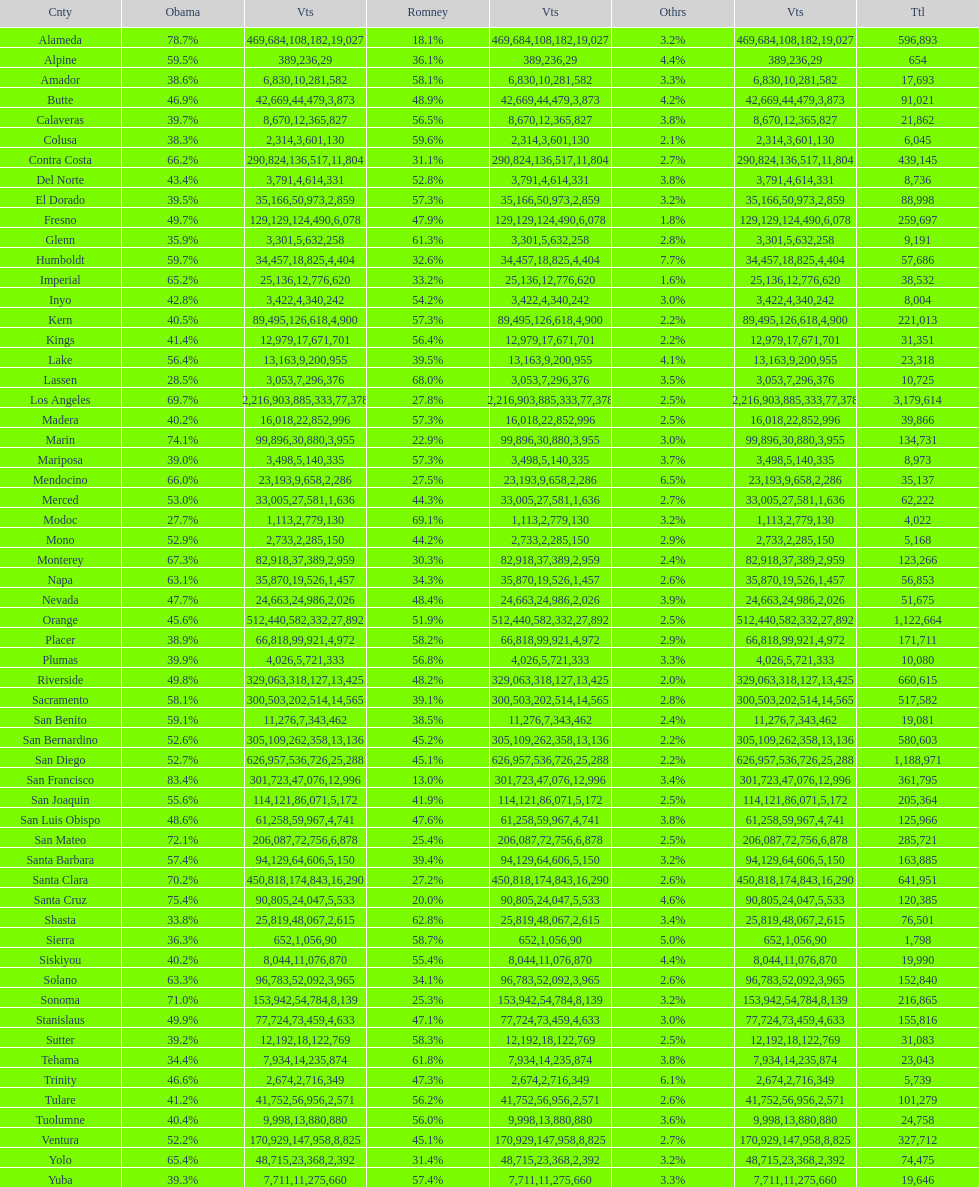Which county had the lower percentage votes for obama: amador, humboldt, or lake? Amador. 